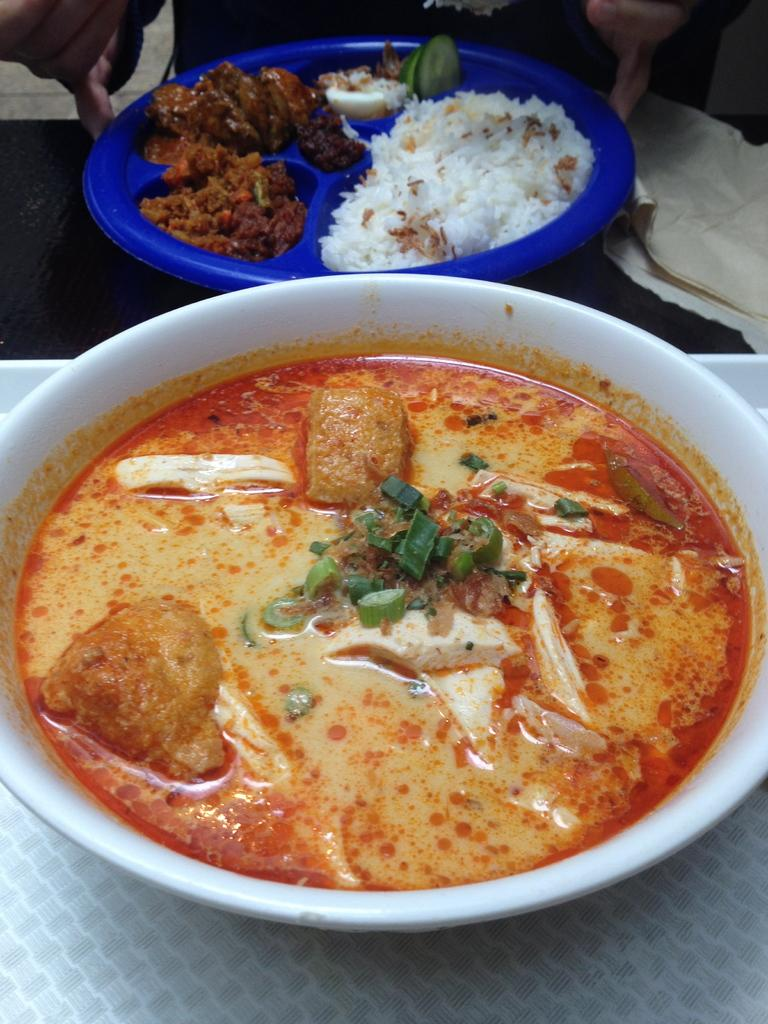What is the main piece of furniture in the picture? There is a table in the picture. What is placed on the table? There is a tray on the table. What can be found on the tray? There are bowls with food items on the tray. Who is present in the image? There is a person present in front of the table. What type of dock can be seen in the image? There is no dock present in the image. Is there a fight happening between the person and the food items in the image? No, there is no fight happening between the person and the food items in the image. 